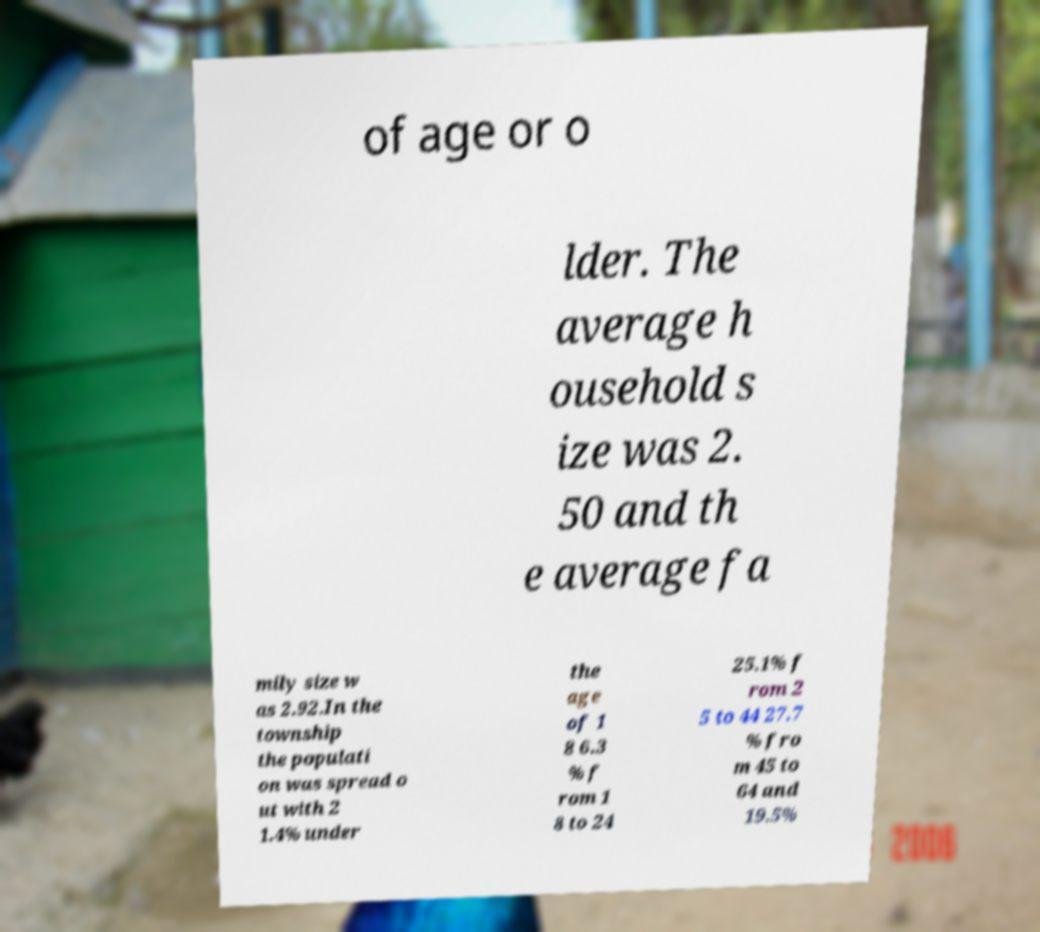I need the written content from this picture converted into text. Can you do that? of age or o lder. The average h ousehold s ize was 2. 50 and th e average fa mily size w as 2.92.In the township the populati on was spread o ut with 2 1.4% under the age of 1 8 6.3 % f rom 1 8 to 24 25.1% f rom 2 5 to 44 27.7 % fro m 45 to 64 and 19.5% 